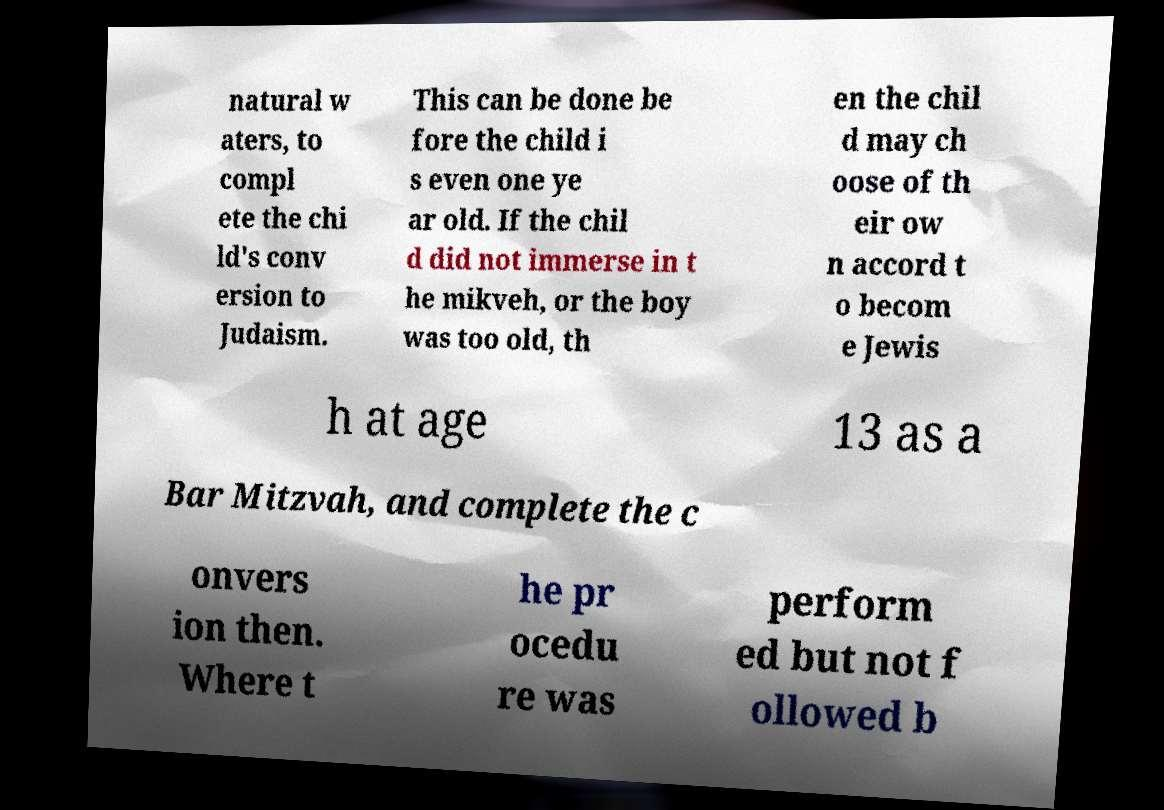What messages or text are displayed in this image? I need them in a readable, typed format. natural w aters, to compl ete the chi ld's conv ersion to Judaism. This can be done be fore the child i s even one ye ar old. If the chil d did not immerse in t he mikveh, or the boy was too old, th en the chil d may ch oose of th eir ow n accord t o becom e Jewis h at age 13 as a Bar Mitzvah, and complete the c onvers ion then. Where t he pr ocedu re was perform ed but not f ollowed b 